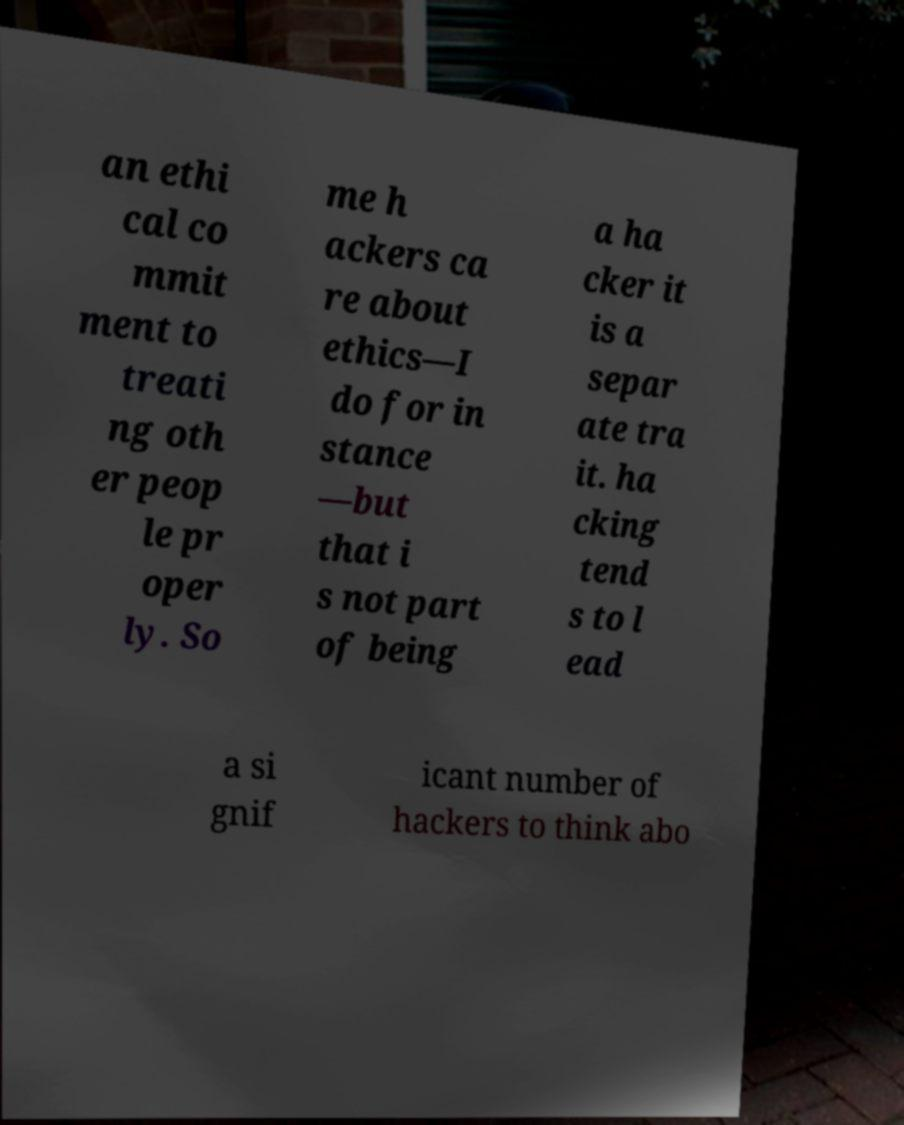Can you read and provide the text displayed in the image?This photo seems to have some interesting text. Can you extract and type it out for me? an ethi cal co mmit ment to treati ng oth er peop le pr oper ly. So me h ackers ca re about ethics—I do for in stance —but that i s not part of being a ha cker it is a separ ate tra it. ha cking tend s to l ead a si gnif icant number of hackers to think abo 